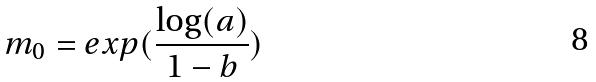Convert formula to latex. <formula><loc_0><loc_0><loc_500><loc_500>m _ { 0 } = e x p ( \frac { \log ( a ) } { 1 - b } )</formula> 